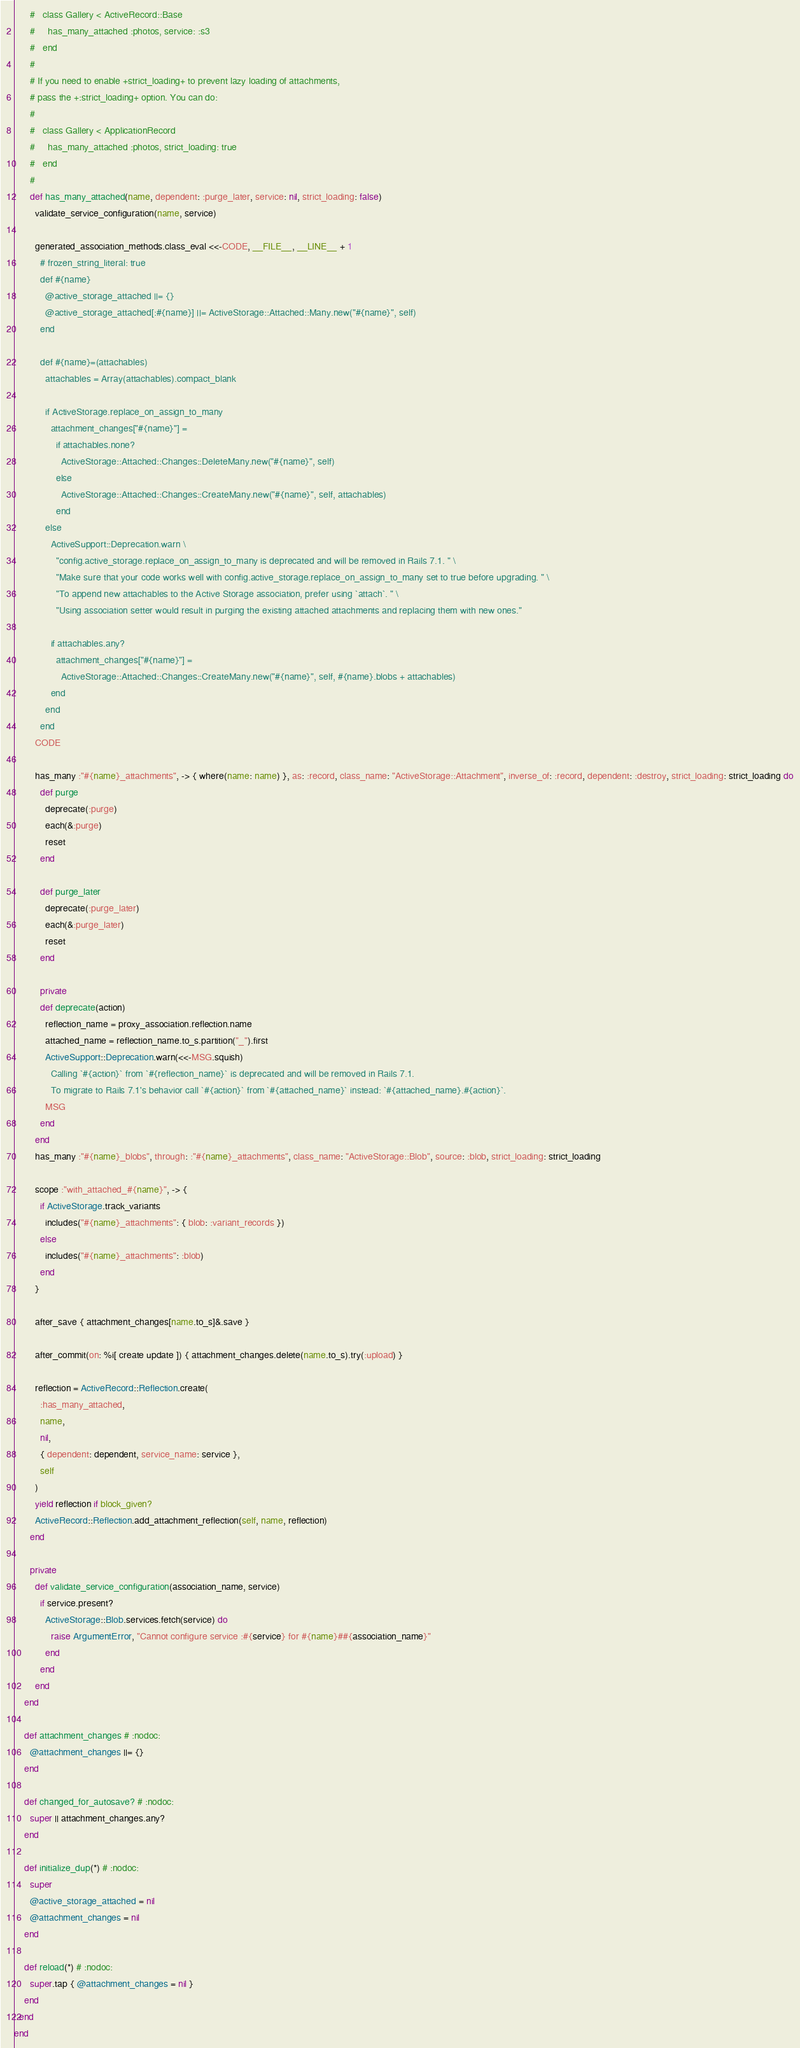<code> <loc_0><loc_0><loc_500><loc_500><_Ruby_>      #   class Gallery < ActiveRecord::Base
      #     has_many_attached :photos, service: :s3
      #   end
      #
      # If you need to enable +strict_loading+ to prevent lazy loading of attachments,
      # pass the +:strict_loading+ option. You can do:
      #
      #   class Gallery < ApplicationRecord
      #     has_many_attached :photos, strict_loading: true
      #   end
      #
      def has_many_attached(name, dependent: :purge_later, service: nil, strict_loading: false)
        validate_service_configuration(name, service)

        generated_association_methods.class_eval <<-CODE, __FILE__, __LINE__ + 1
          # frozen_string_literal: true
          def #{name}
            @active_storage_attached ||= {}
            @active_storage_attached[:#{name}] ||= ActiveStorage::Attached::Many.new("#{name}", self)
          end

          def #{name}=(attachables)
            attachables = Array(attachables).compact_blank

            if ActiveStorage.replace_on_assign_to_many
              attachment_changes["#{name}"] =
                if attachables.none?
                  ActiveStorage::Attached::Changes::DeleteMany.new("#{name}", self)
                else
                  ActiveStorage::Attached::Changes::CreateMany.new("#{name}", self, attachables)
                end
            else
              ActiveSupport::Deprecation.warn \
                "config.active_storage.replace_on_assign_to_many is deprecated and will be removed in Rails 7.1. " \
                "Make sure that your code works well with config.active_storage.replace_on_assign_to_many set to true before upgrading. " \
                "To append new attachables to the Active Storage association, prefer using `attach`. " \
                "Using association setter would result in purging the existing attached attachments and replacing them with new ones."

              if attachables.any?
                attachment_changes["#{name}"] =
                  ActiveStorage::Attached::Changes::CreateMany.new("#{name}", self, #{name}.blobs + attachables)
              end
            end
          end
        CODE

        has_many :"#{name}_attachments", -> { where(name: name) }, as: :record, class_name: "ActiveStorage::Attachment", inverse_of: :record, dependent: :destroy, strict_loading: strict_loading do
          def purge
            deprecate(:purge)
            each(&:purge)
            reset
          end

          def purge_later
            deprecate(:purge_later)
            each(&:purge_later)
            reset
          end

          private
          def deprecate(action)
            reflection_name = proxy_association.reflection.name
            attached_name = reflection_name.to_s.partition("_").first
            ActiveSupport::Deprecation.warn(<<-MSG.squish)
              Calling `#{action}` from `#{reflection_name}` is deprecated and will be removed in Rails 7.1.
              To migrate to Rails 7.1's behavior call `#{action}` from `#{attached_name}` instead: `#{attached_name}.#{action}`.
            MSG
          end
        end
        has_many :"#{name}_blobs", through: :"#{name}_attachments", class_name: "ActiveStorage::Blob", source: :blob, strict_loading: strict_loading

        scope :"with_attached_#{name}", -> {
          if ActiveStorage.track_variants
            includes("#{name}_attachments": { blob: :variant_records })
          else
            includes("#{name}_attachments": :blob)
          end
        }

        after_save { attachment_changes[name.to_s]&.save }

        after_commit(on: %i[ create update ]) { attachment_changes.delete(name.to_s).try(:upload) }

        reflection = ActiveRecord::Reflection.create(
          :has_many_attached,
          name,
          nil,
          { dependent: dependent, service_name: service },
          self
        )
        yield reflection if block_given?
        ActiveRecord::Reflection.add_attachment_reflection(self, name, reflection)
      end

      private
        def validate_service_configuration(association_name, service)
          if service.present?
            ActiveStorage::Blob.services.fetch(service) do
              raise ArgumentError, "Cannot configure service :#{service} for #{name}##{association_name}"
            end
          end
        end
    end

    def attachment_changes # :nodoc:
      @attachment_changes ||= {}
    end

    def changed_for_autosave? # :nodoc:
      super || attachment_changes.any?
    end

    def initialize_dup(*) # :nodoc:
      super
      @active_storage_attached = nil
      @attachment_changes = nil
    end

    def reload(*) # :nodoc:
      super.tap { @attachment_changes = nil }
    end
  end
end
</code> 